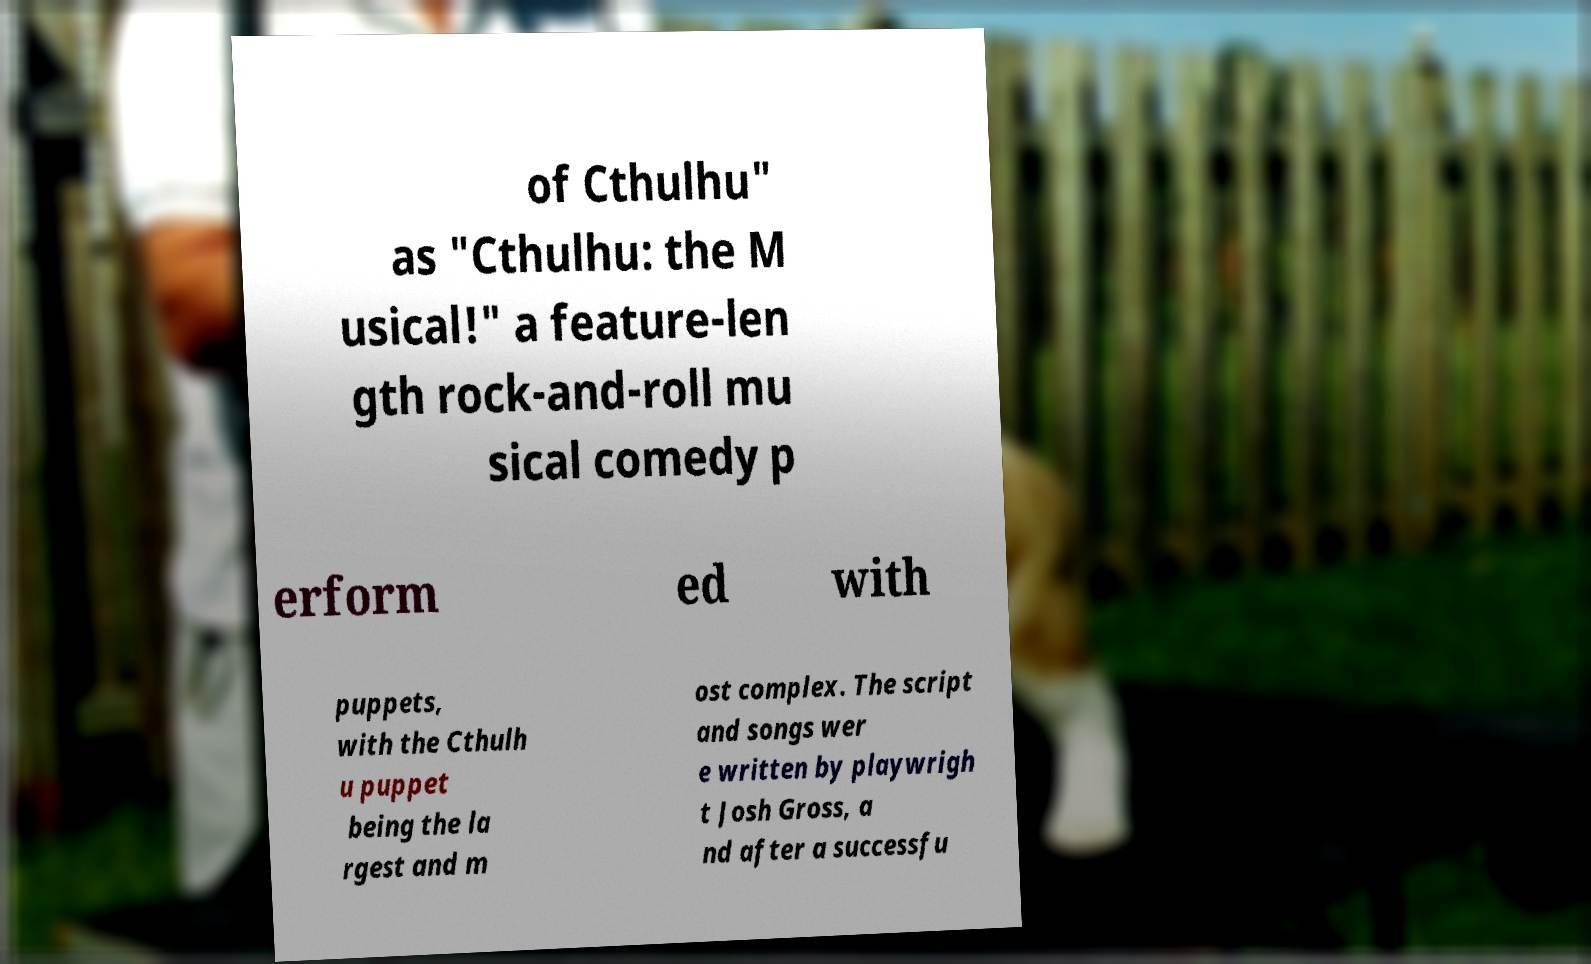Could you assist in decoding the text presented in this image and type it out clearly? of Cthulhu" as "Cthulhu: the M usical!" a feature-len gth rock-and-roll mu sical comedy p erform ed with puppets, with the Cthulh u puppet being the la rgest and m ost complex. The script and songs wer e written by playwrigh t Josh Gross, a nd after a successfu 